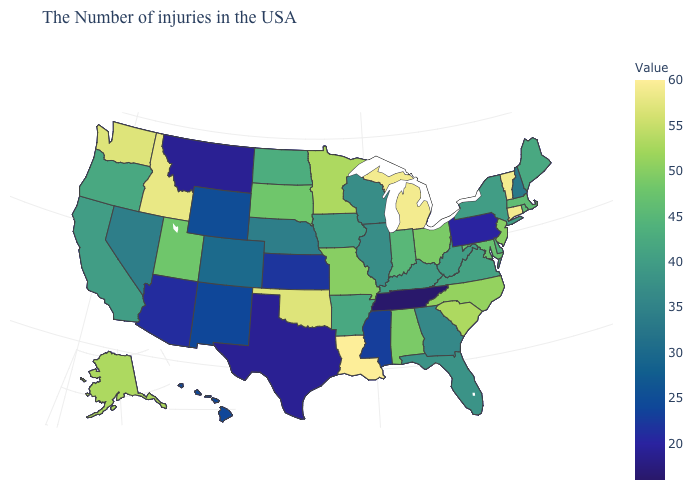Which states hav the highest value in the South?
Be succinct. Louisiana. Does the map have missing data?
Give a very brief answer. No. Among the states that border West Virginia , which have the highest value?
Short answer required. Ohio. Is the legend a continuous bar?
Be succinct. Yes. 